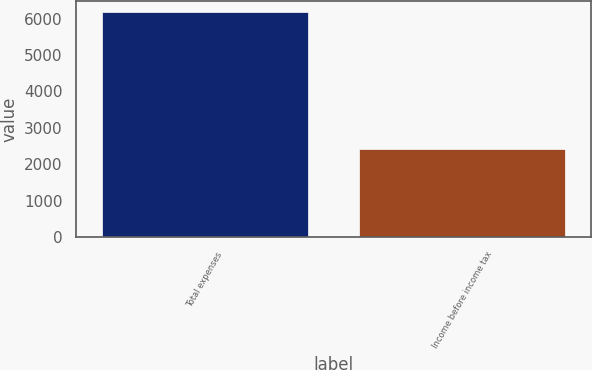Convert chart to OTSL. <chart><loc_0><loc_0><loc_500><loc_500><bar_chart><fcel>Total expenses<fcel>Income before income tax<nl><fcel>6176<fcel>2405<nl></chart> 